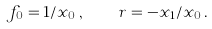<formula> <loc_0><loc_0><loc_500><loc_500>f _ { 0 } = 1 / x _ { 0 } \, , \quad r = - x _ { 1 } / x _ { 0 } \, .</formula> 